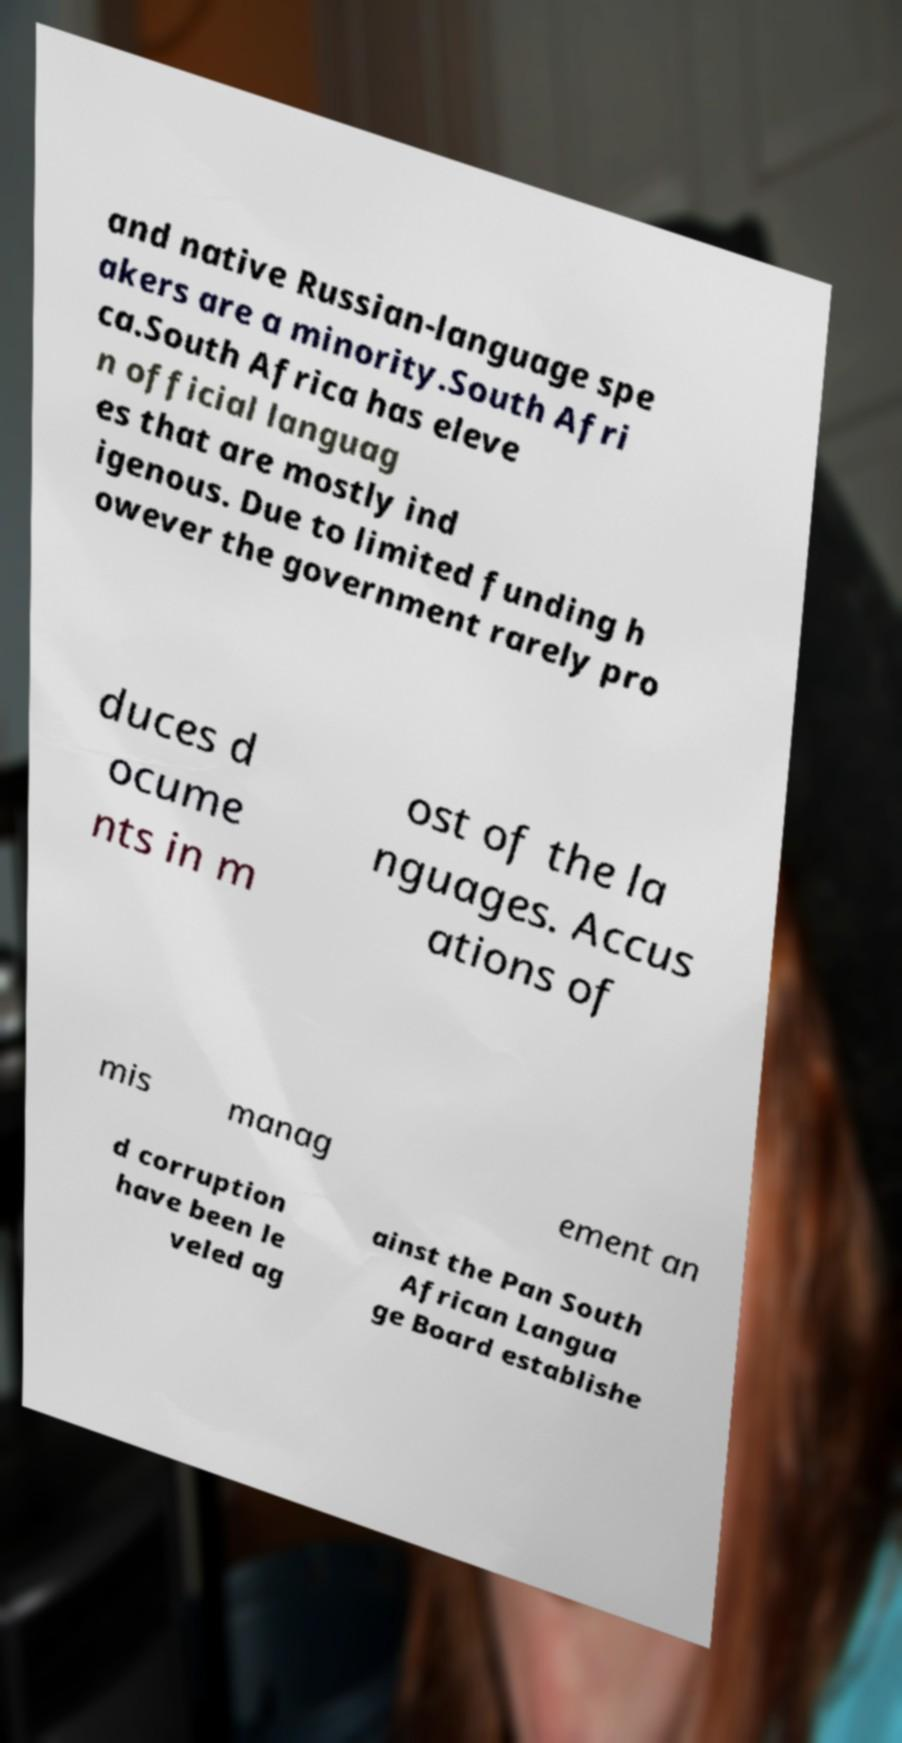Could you extract and type out the text from this image? and native Russian-language spe akers are a minority.South Afri ca.South Africa has eleve n official languag es that are mostly ind igenous. Due to limited funding h owever the government rarely pro duces d ocume nts in m ost of the la nguages. Accus ations of mis manag ement an d corruption have been le veled ag ainst the Pan South African Langua ge Board establishe 